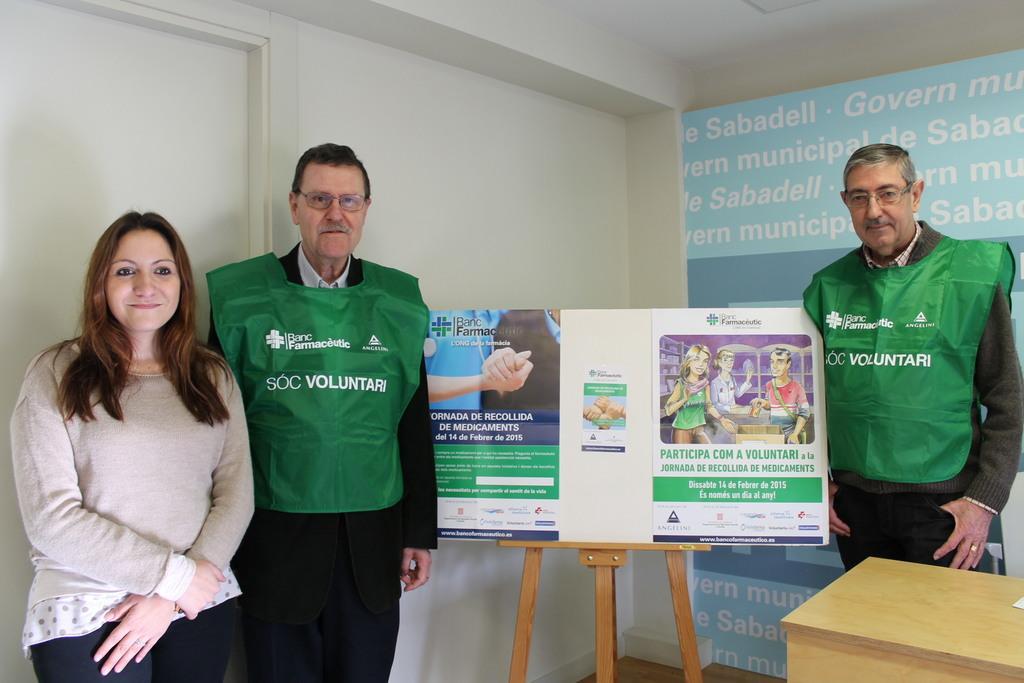Could you give a brief overview of what you see in this image? In this picture I see 2 men and a woman who are standing and I see that these 2 men are wearing same dress and I see a board on which there is something written. In the background I see the wall and I see the door on the left side of this image and I see something is written on the right side of this image and I see a brown color thing in front. 